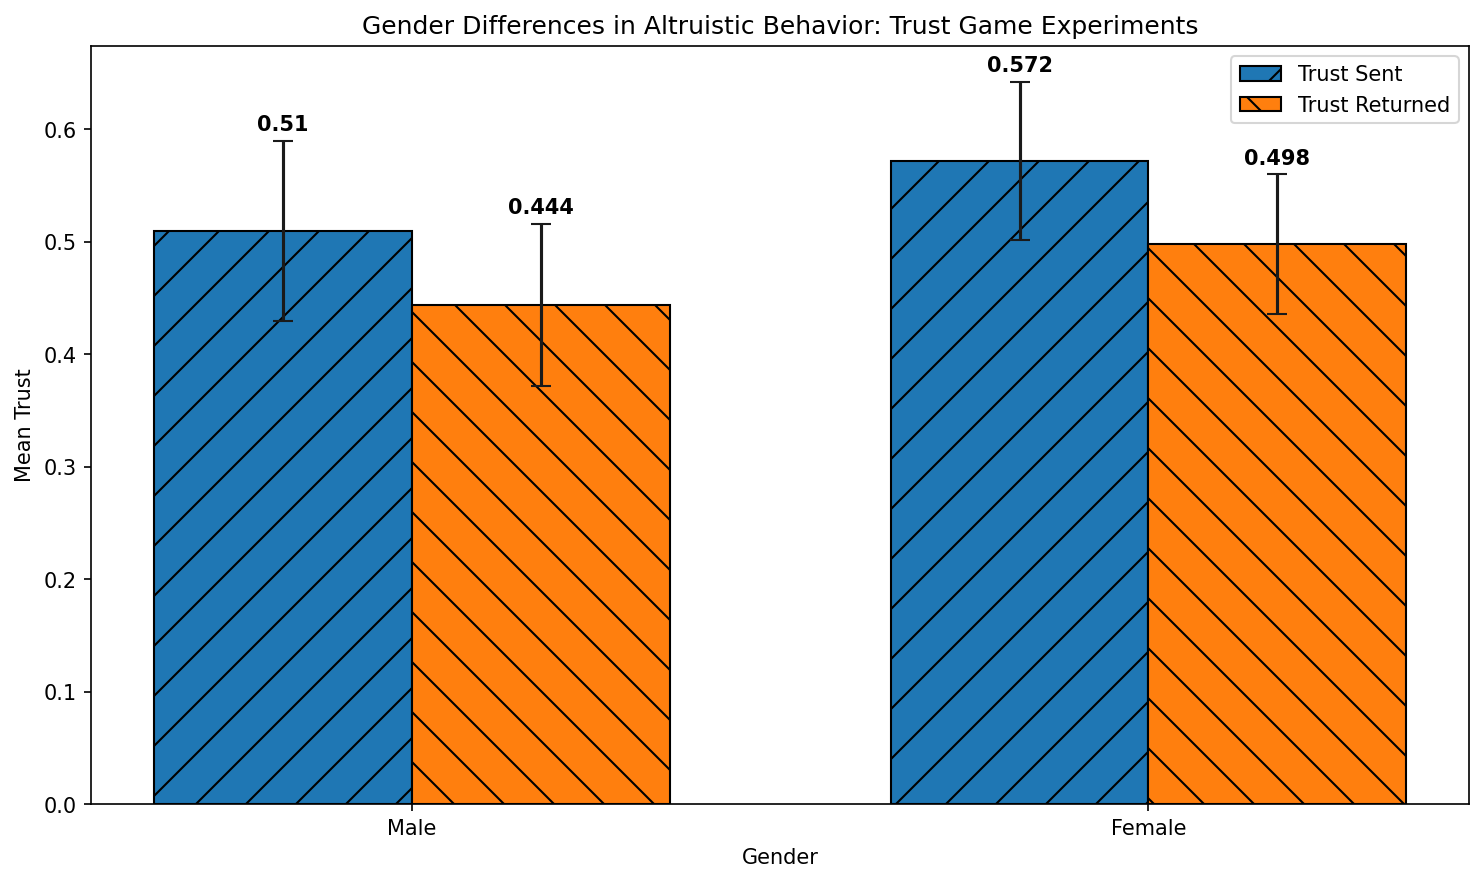What is the mean trust sent by females, and how does it compare to the mean trust returned by females? The mean trust sent by females is represented by the height of the first bar for females in blue, and the mean trust returned is represented by the height of the second bar for females in orange. The figure shows that the mean trust sent by females is approximately 0.57, while the mean trust returned is approximately 0.50.
Answer: Trust sent: 0.57, Trust returned: 0.50 Which gender shows a higher mean trust sent, and what is the difference between the two genders? To compare the mean trust sent between males and females, we look at the heights of the blue bars for each gender. The figure shows that females have a higher mean trust sent (approximately 0.57) compared to males (approximately 0.51). The difference is calculated as 0.57 - 0.51 = 0.06.
Answer: Females, 0.06 What is the standard deviation (SD) of trust returned for males, and how does it compare to the standard deviation for females? The standard deviation of trust returned is indicated by the error bars. For males (orange bar), the SD is approximately 0.07, while for females (orange bar), the SD is approximately 0.06.
Answer: Males: 0.07, Females: 0.06 Are males or females more consistent in trust returned as indicated by the standard deviations? Consistency can be inferred from smaller standard deviations. The error bars show that females have a smaller SD (approximately 0.06) compared to males (approximately 0.07) in trust returned, indicating greater consistency among females.
Answer: Females What is the combined mean trust returned by both genders? To find the combined mean trust returned by both genders, we average the mean trust returned for males (approximately 0.44) and females (approximately 0.50). The calculation is (0.44 + 0.50) / 2 = 0.47.
Answer: 0.47 Which bar has the highest mean value, and what does it represent? The bar with the highest mean value is the blue bar for females, with a mean trust sent of approximately 0.57.
Answer: Blue bar for females representing mean trust sent By how much does the mean trust sent by males differ from their mean trust returned? The difference is calculated by subtracting the mean trust returned by males (approximately 0.44) from the mean trust sent by males (approximately 0.51). The calculation is 0.51 - 0.44 = 0.07.
Answer: 0.07 How does the mean trust sent by males compare to the trust sent by females in terms of error bars? The means can be visually compared by looking at the heights of the blue bars, and the error bars show the standard deviations. Males have a mean trust sent of approximately 0.51 with an SD of 0.08, whereas females have a mean trust sent of approximately 0.57 with an SD of 0.07. Both groups show some variability, but females have a higher mean with slightly less variation.
Answer: Females have higher mean with slightly less variation 